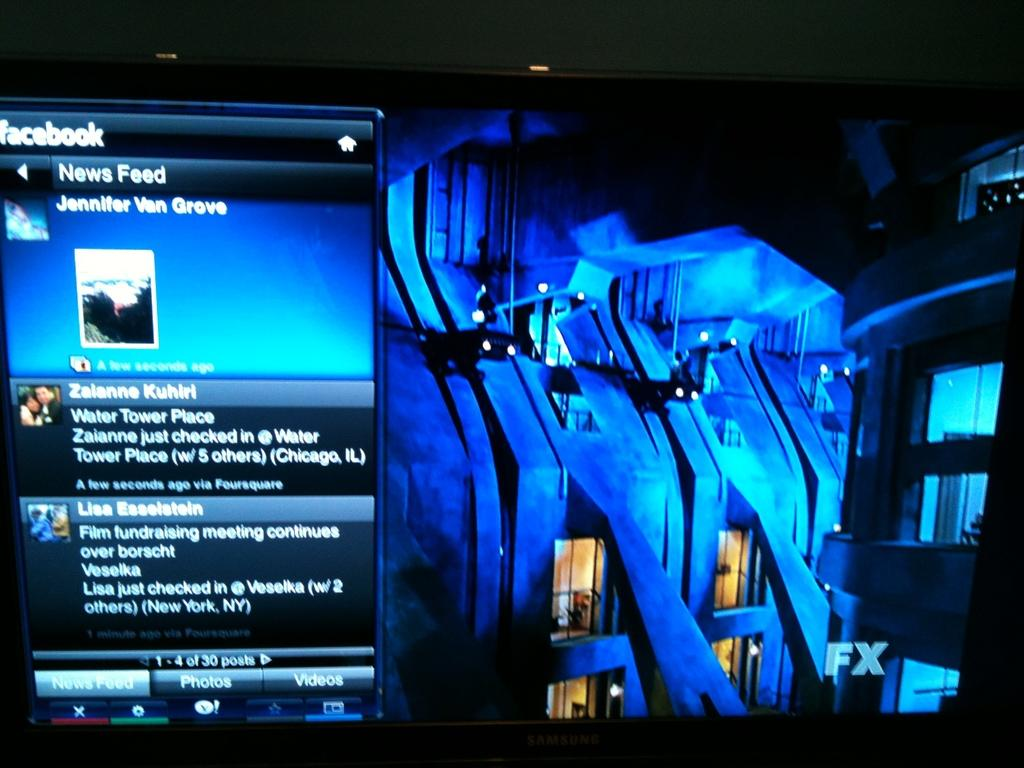<image>
Share a concise interpretation of the image provided. A computer monitor with a page open to Facebook news feed next to an image of a building. 